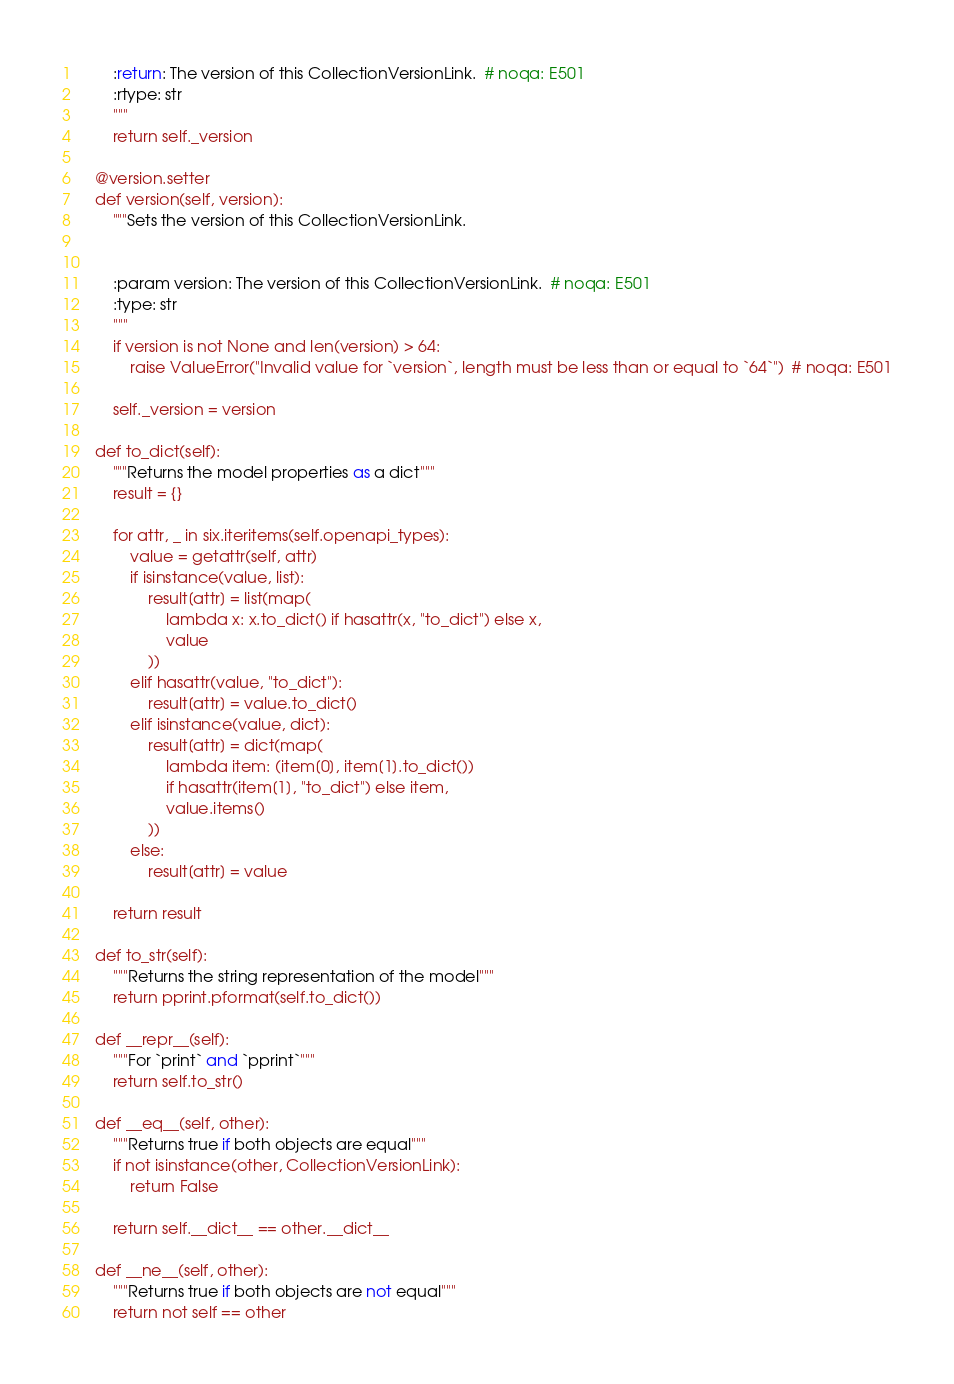<code> <loc_0><loc_0><loc_500><loc_500><_Python_>
        :return: The version of this CollectionVersionLink.  # noqa: E501
        :rtype: str
        """
        return self._version

    @version.setter
    def version(self, version):
        """Sets the version of this CollectionVersionLink.


        :param version: The version of this CollectionVersionLink.  # noqa: E501
        :type: str
        """
        if version is not None and len(version) > 64:
            raise ValueError("Invalid value for `version`, length must be less than or equal to `64`")  # noqa: E501

        self._version = version

    def to_dict(self):
        """Returns the model properties as a dict"""
        result = {}

        for attr, _ in six.iteritems(self.openapi_types):
            value = getattr(self, attr)
            if isinstance(value, list):
                result[attr] = list(map(
                    lambda x: x.to_dict() if hasattr(x, "to_dict") else x,
                    value
                ))
            elif hasattr(value, "to_dict"):
                result[attr] = value.to_dict()
            elif isinstance(value, dict):
                result[attr] = dict(map(
                    lambda item: (item[0], item[1].to_dict())
                    if hasattr(item[1], "to_dict") else item,
                    value.items()
                ))
            else:
                result[attr] = value

        return result

    def to_str(self):
        """Returns the string representation of the model"""
        return pprint.pformat(self.to_dict())

    def __repr__(self):
        """For `print` and `pprint`"""
        return self.to_str()

    def __eq__(self, other):
        """Returns true if both objects are equal"""
        if not isinstance(other, CollectionVersionLink):
            return False

        return self.__dict__ == other.__dict__

    def __ne__(self, other):
        """Returns true if both objects are not equal"""
        return not self == other
</code> 